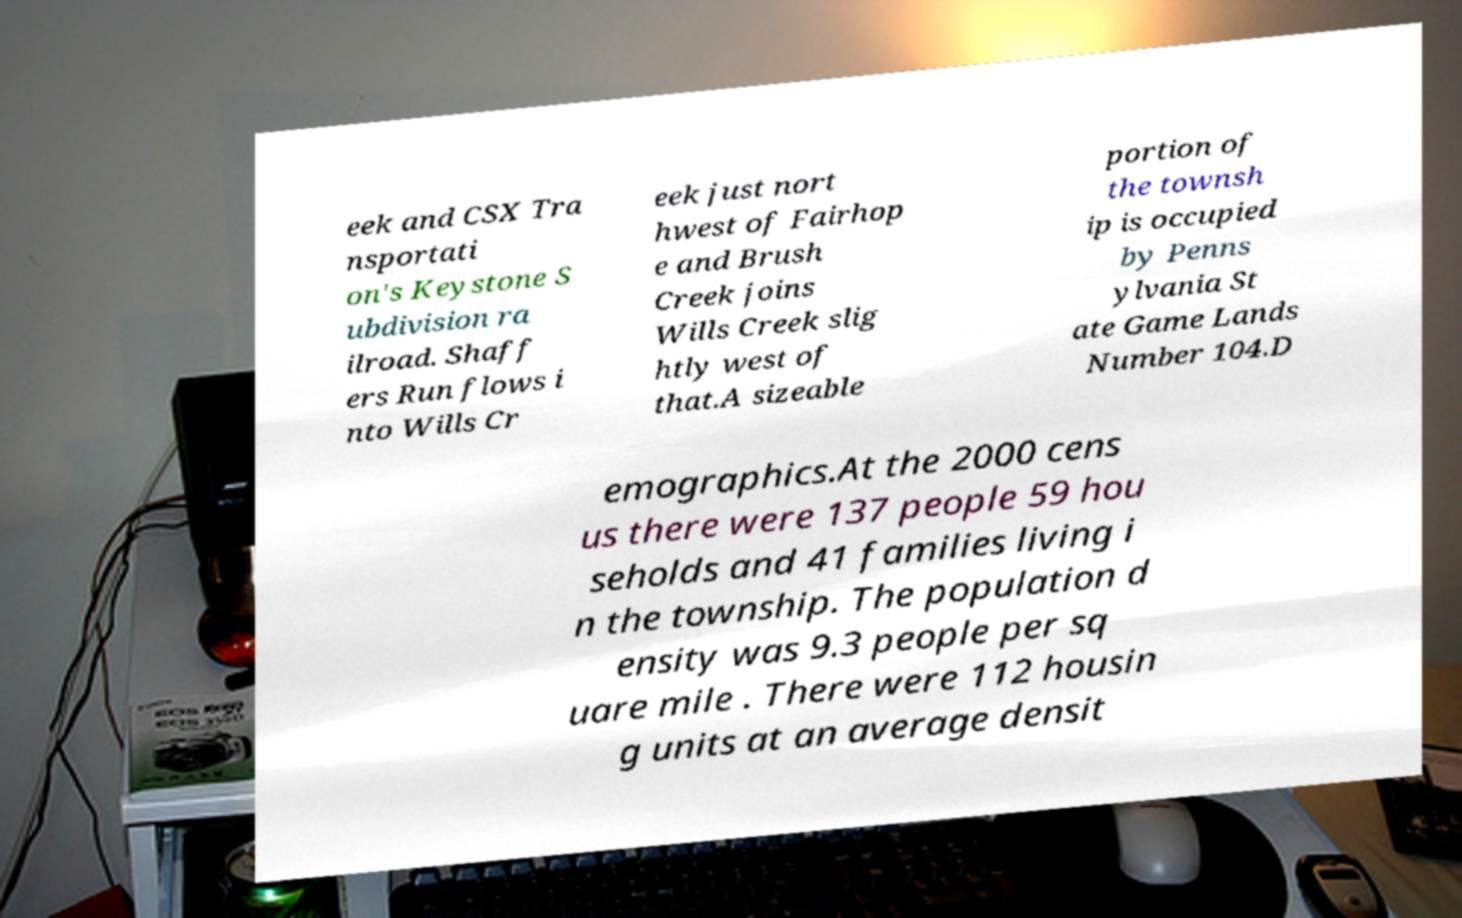What messages or text are displayed in this image? I need them in a readable, typed format. eek and CSX Tra nsportati on's Keystone S ubdivision ra ilroad. Shaff ers Run flows i nto Wills Cr eek just nort hwest of Fairhop e and Brush Creek joins Wills Creek slig htly west of that.A sizeable portion of the townsh ip is occupied by Penns ylvania St ate Game Lands Number 104.D emographics.At the 2000 cens us there were 137 people 59 hou seholds and 41 families living i n the township. The population d ensity was 9.3 people per sq uare mile . There were 112 housin g units at an average densit 